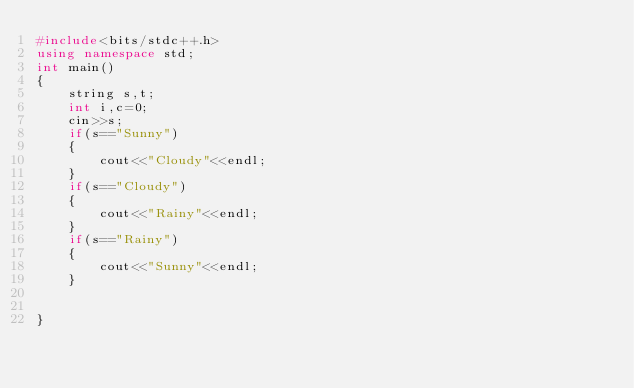<code> <loc_0><loc_0><loc_500><loc_500><_C++_>#include<bits/stdc++.h>
using namespace std;
int main()
{
    string s,t;
    int i,c=0;
    cin>>s;
    if(s=="Sunny")
    {
        cout<<"Cloudy"<<endl;
    }
    if(s=="Cloudy")
    {
        cout<<"Rainy"<<endl;
    }
    if(s=="Rainy")
    {
        cout<<"Sunny"<<endl;
    }


}
</code> 